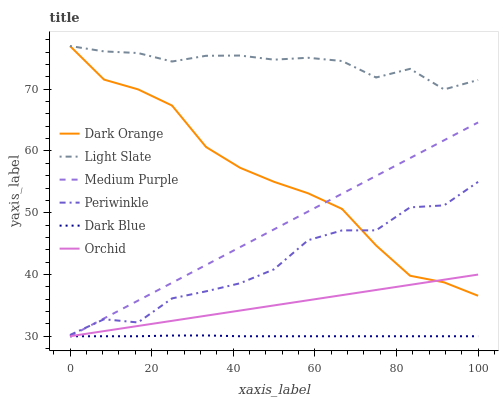Does Dark Blue have the minimum area under the curve?
Answer yes or no. Yes. Does Light Slate have the maximum area under the curve?
Answer yes or no. Yes. Does Medium Purple have the minimum area under the curve?
Answer yes or no. No. Does Medium Purple have the maximum area under the curve?
Answer yes or no. No. Is Orchid the smoothest?
Answer yes or no. Yes. Is Periwinkle the roughest?
Answer yes or no. Yes. Is Light Slate the smoothest?
Answer yes or no. No. Is Light Slate the roughest?
Answer yes or no. No. Does Medium Purple have the lowest value?
Answer yes or no. Yes. Does Light Slate have the lowest value?
Answer yes or no. No. Does Light Slate have the highest value?
Answer yes or no. Yes. Does Medium Purple have the highest value?
Answer yes or no. No. Is Dark Blue less than Periwinkle?
Answer yes or no. Yes. Is Periwinkle greater than Dark Blue?
Answer yes or no. Yes. Does Medium Purple intersect Orchid?
Answer yes or no. Yes. Is Medium Purple less than Orchid?
Answer yes or no. No. Is Medium Purple greater than Orchid?
Answer yes or no. No. Does Dark Blue intersect Periwinkle?
Answer yes or no. No. 